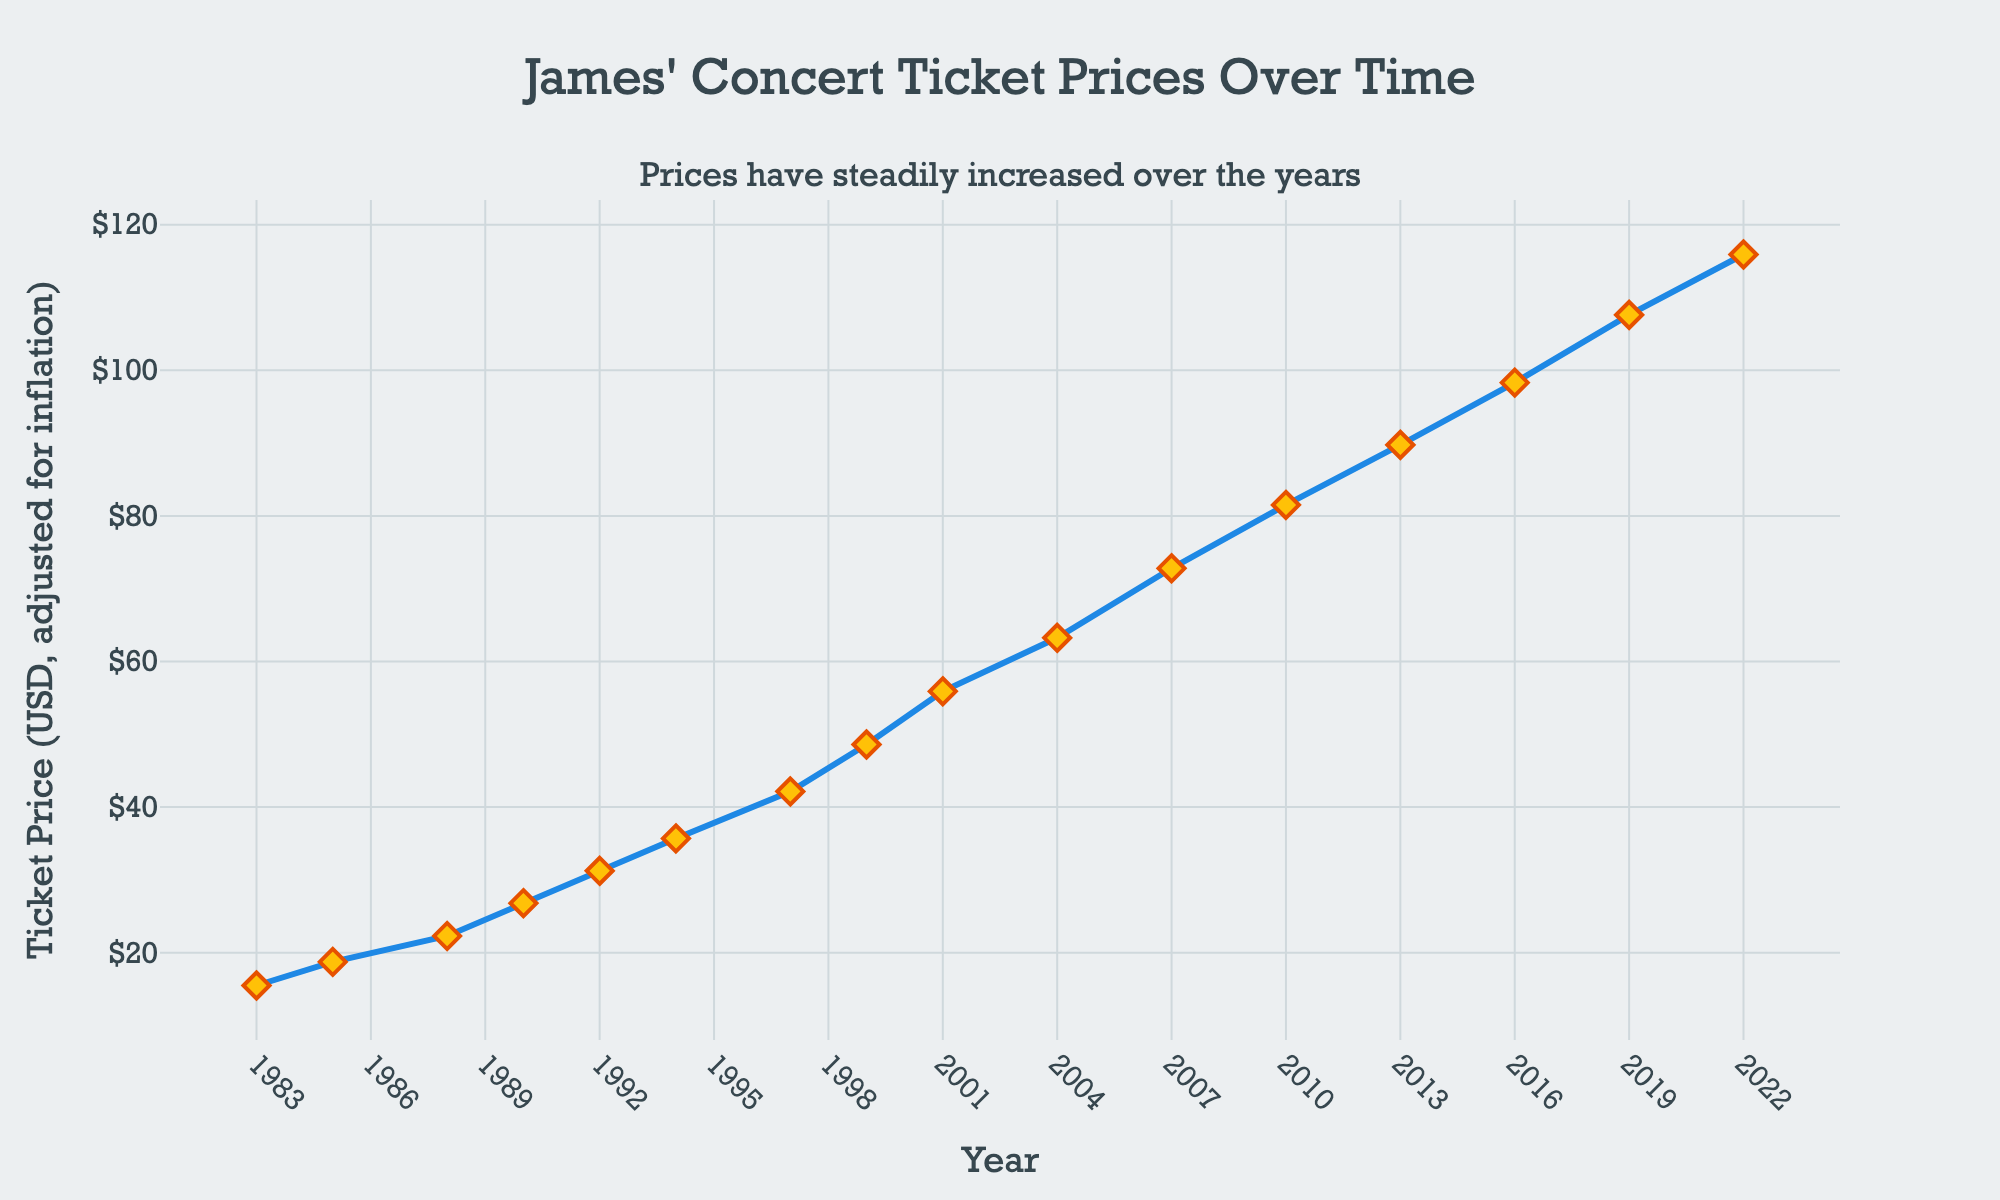What is the ticket price in 2013? The ticket price for the year 2013 is directly visible from the line chart.
Answer: $89.75 Which year saw the highest concert ticket price? By visually inspecting the line chart, the highest point on the y-axis corresponds to the year 2022.
Answer: 2022 How much did the ticket price increase from 1983 to 2022? To find this, subtract the ticket price in 1983 from the ticket price in 2022: $115.90 - $15.50.
Answer: $100.40 Is the trend of ticket prices increasing, decreasing, or stable over time? Observing the line chart shows a consistent upward slope from 1983 to 2022, indicating an increasing trend.
Answer: Increasing What was the average ticket price from 1990 to 2000? Average ticket price = (Sum of ticket prices from 1990, 1992, 1994, 1997, 1999) / 5 = (26.80 + 31.25 + 35.70 + 42.15 + 48.60) / 5 = 184.50 / 5.
Answer: $36.90 In which period did the ticket price experience the most significant increase? Identify the two points with the largest vertical distance between consecutive years. From 2004 ($63.25) to 2007 ($72.80), the increase is $72.80 - $63.25 = $9.55. This is the largest increase observed.
Answer: 2004-2007 How much did ticket prices increase between 1988 and 1992? The increase is calculated as the difference between the ticket prices in 1992 and 1988: $31.25 - $22.30.
Answer: $8.95 Which years are displayed on the x-axis at a tick interval of 3? Starting from 1983 at a tick interval of 3, the years displayed on the x-axis are 1983, 1986, 1989, 1992, 1995, and so on.
Answer: 1983, 1986, 1989, 1992, 1995.. What is the annotation text on the chart? The annotation text is stated directly on the chart: "Prices have steadily increased over the years."
Answer: Prices have steadily increased over the years Do ticket prices exceed $100 before 2019? By looking at the chart, the ticket prices exceed $100 only in 2019, which means ticket prices do not exceed $100 before 2019.
Answer: No 